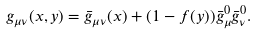Convert formula to latex. <formula><loc_0><loc_0><loc_500><loc_500>g _ { \mu \nu } ( x , y ) = \bar { g } _ { \mu \nu } ( x ) + ( 1 - f ( y ) ) \bar { g } _ { \mu } ^ { 0 } \bar { g } _ { \nu } ^ { 0 } .</formula> 